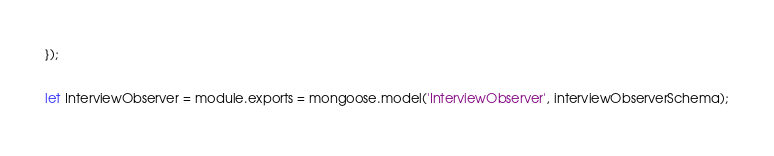Convert code to text. <code><loc_0><loc_0><loc_500><loc_500><_JavaScript_>});

let InterviewObserver = module.exports = mongoose.model('InterviewObserver', interviewObserverSchema);</code> 